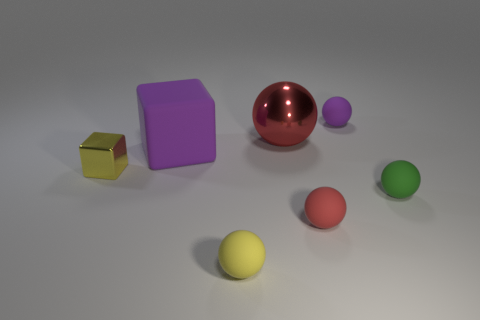What number of other things are the same shape as the red rubber object?
Your response must be concise. 4. There is a small thing that is behind the metal sphere; is there a thing that is to the left of it?
Provide a succinct answer. Yes. What number of metallic objects are either small balls or small purple objects?
Offer a terse response. 0. What is the sphere that is both behind the purple block and right of the large red metal sphere made of?
Offer a terse response. Rubber. There is a purple thing on the left side of the small object behind the yellow block; are there any blocks in front of it?
Your answer should be compact. Yes. There is a red thing that is made of the same material as the small yellow cube; what shape is it?
Offer a very short reply. Sphere. Is the number of small rubber spheres that are on the left side of the red matte thing less than the number of small metallic blocks right of the metal block?
Provide a succinct answer. No. What number of tiny objects are either yellow matte objects or shiny spheres?
Your answer should be compact. 1. There is a purple thing that is on the right side of the tiny yellow ball; does it have the same shape as the rubber object in front of the tiny red rubber ball?
Offer a very short reply. Yes. There is a thing left of the purple matte cube behind the tiny red thing that is right of the large purple matte thing; how big is it?
Provide a succinct answer. Small. 